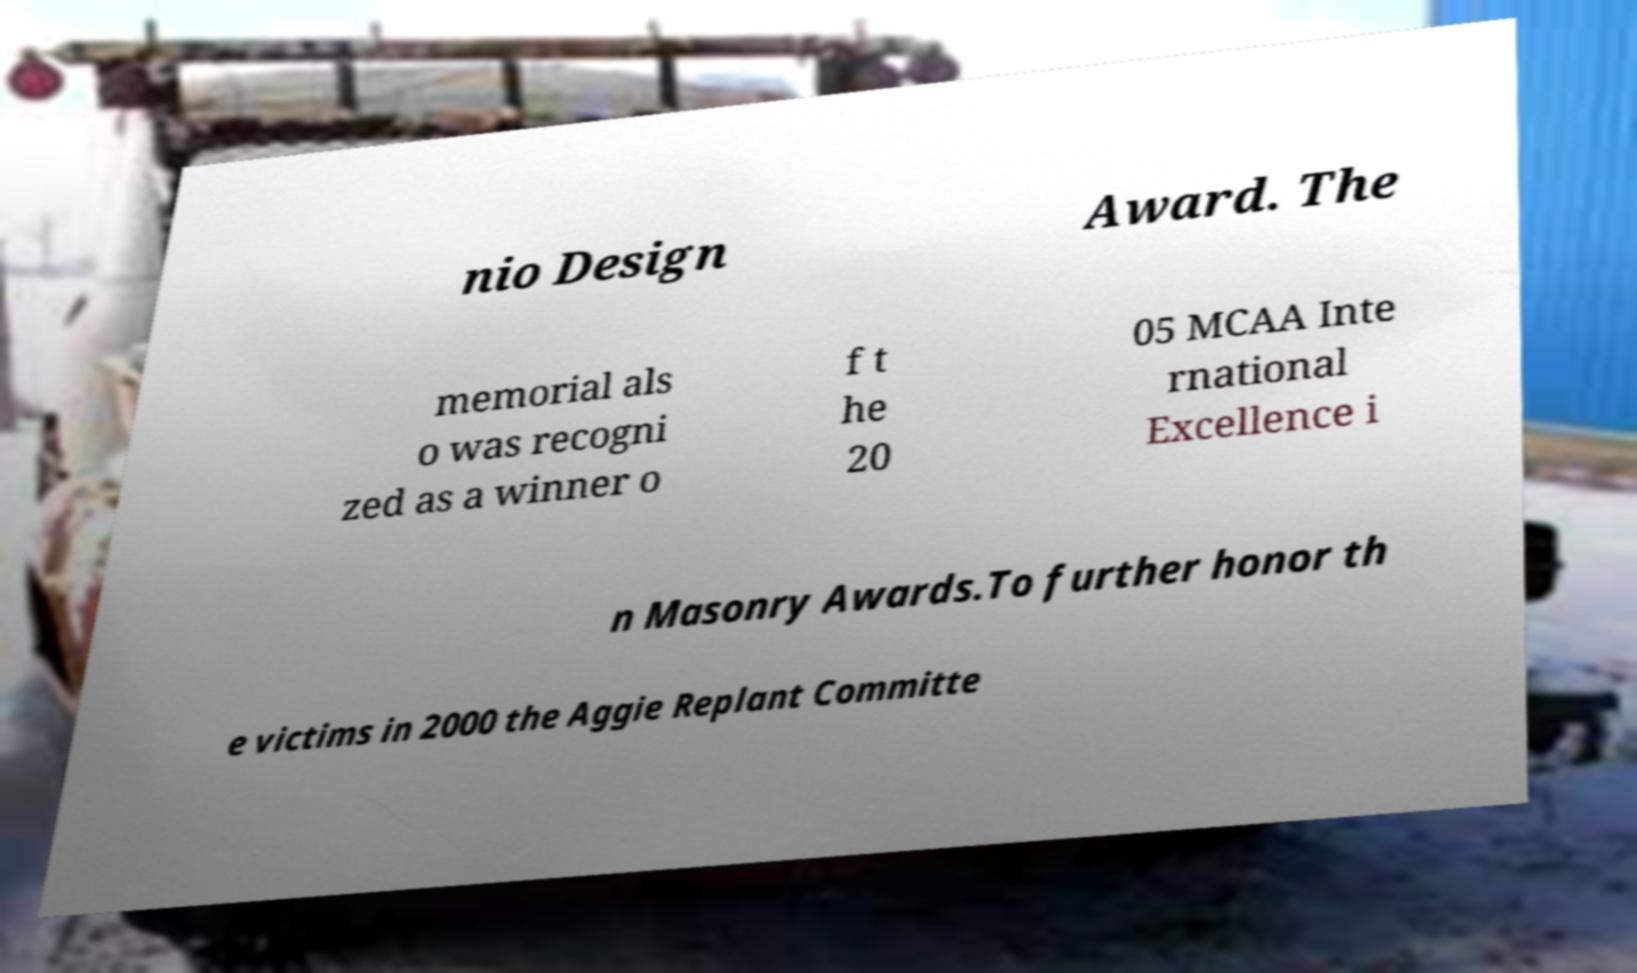I need the written content from this picture converted into text. Can you do that? nio Design Award. The memorial als o was recogni zed as a winner o f t he 20 05 MCAA Inte rnational Excellence i n Masonry Awards.To further honor th e victims in 2000 the Aggie Replant Committe 